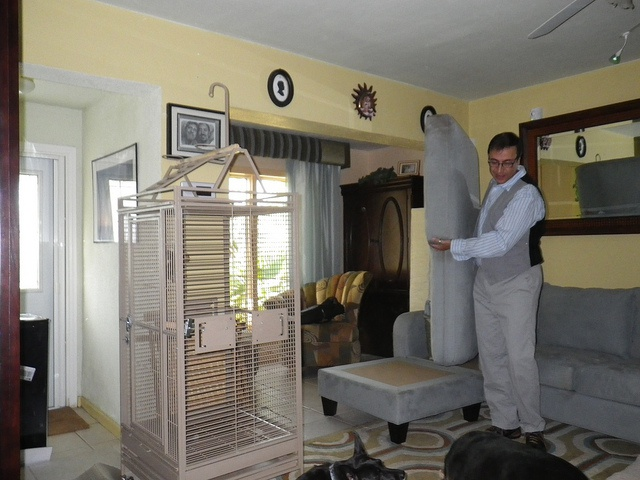Describe the objects in this image and their specific colors. I can see people in black and gray tones, couch in black and gray tones, chair in black, olive, and gray tones, couch in black, olive, and gray tones, and dog in black and gray tones in this image. 